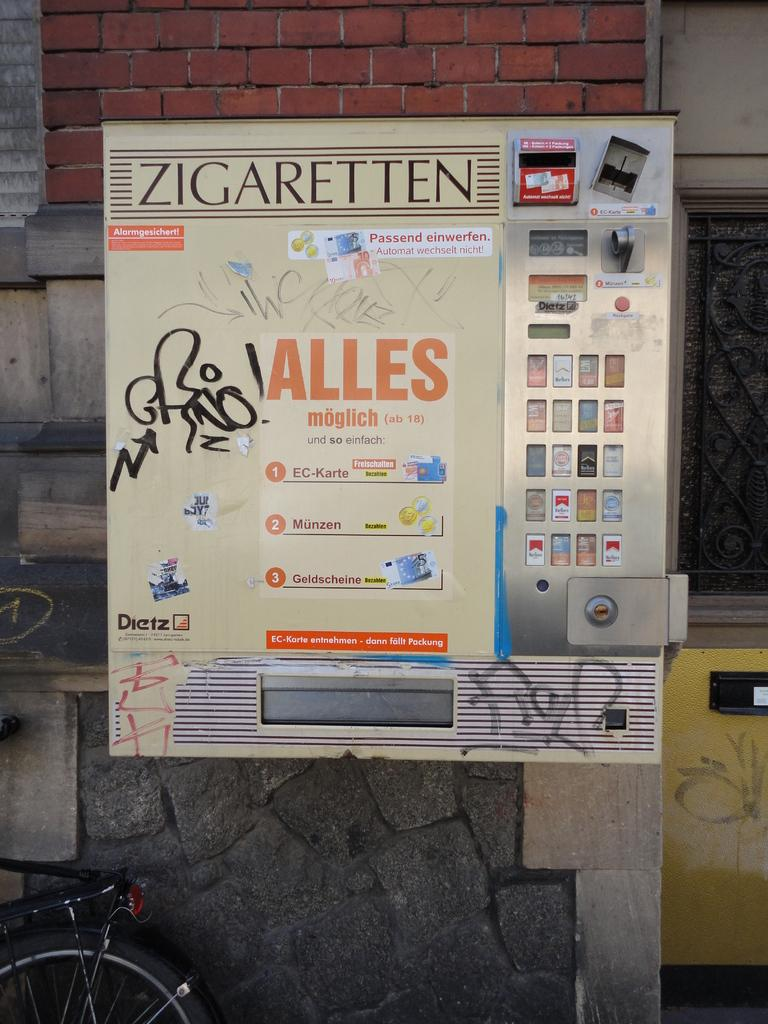<image>
Offer a succinct explanation of the picture presented. A large sign that says Zigaretten on the top of it. 